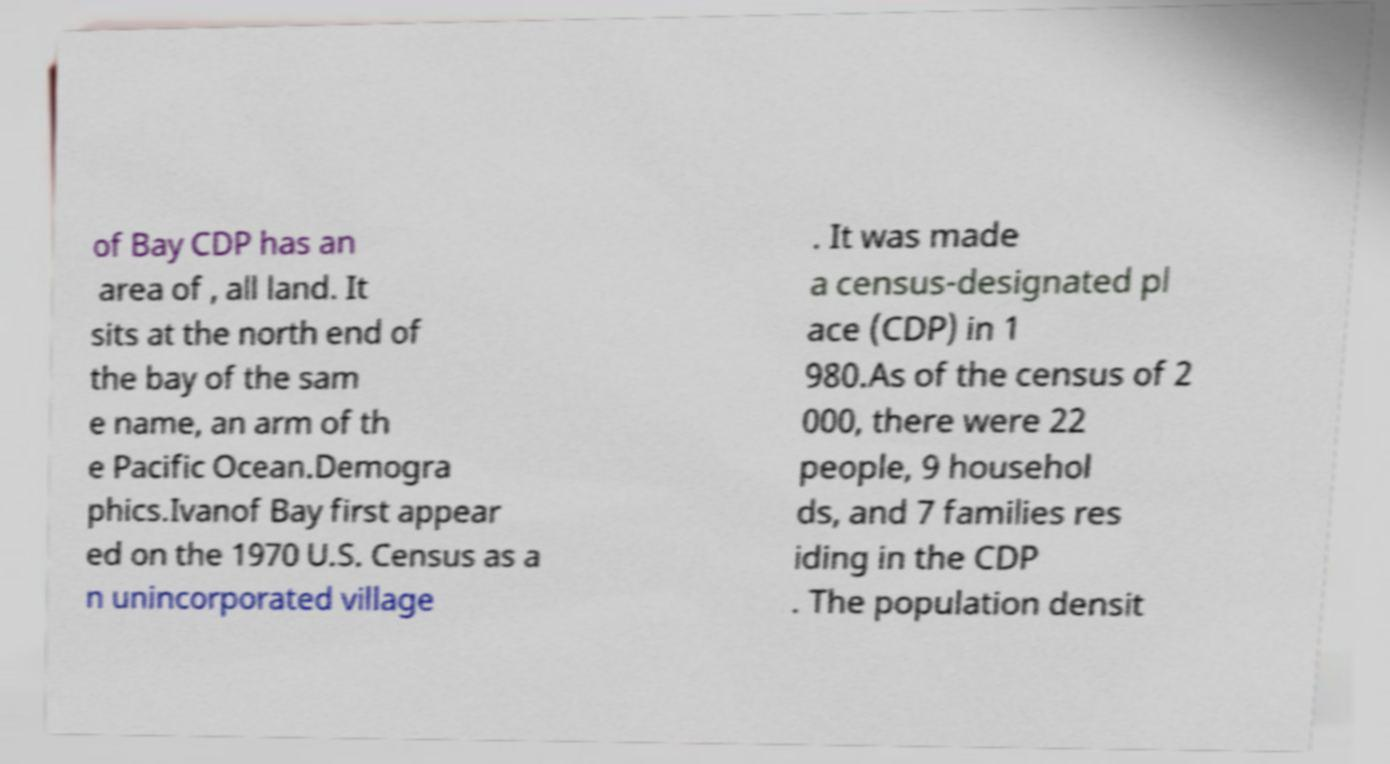Please identify and transcribe the text found in this image. of Bay CDP has an area of , all land. It sits at the north end of the bay of the sam e name, an arm of th e Pacific Ocean.Demogra phics.Ivanof Bay first appear ed on the 1970 U.S. Census as a n unincorporated village . It was made a census-designated pl ace (CDP) in 1 980.As of the census of 2 000, there were 22 people, 9 househol ds, and 7 families res iding in the CDP . The population densit 